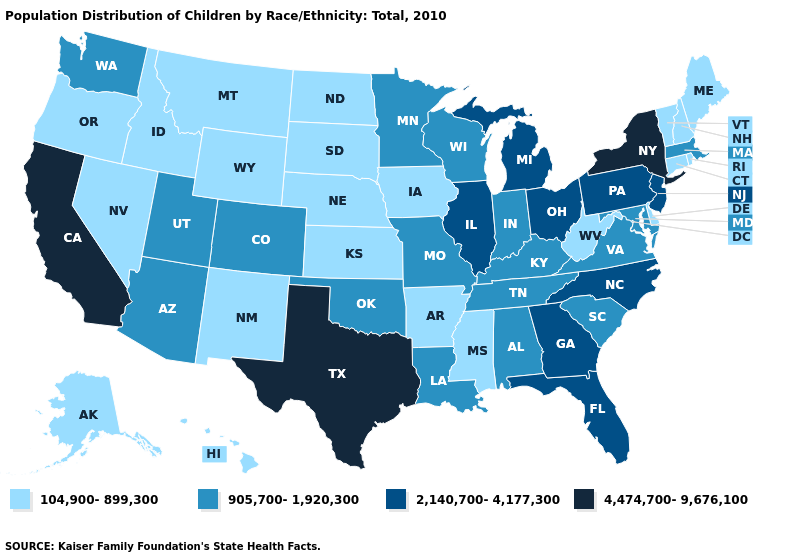What is the highest value in states that border Connecticut?
Keep it brief. 4,474,700-9,676,100. Does Florida have the highest value in the USA?
Answer briefly. No. Does the map have missing data?
Be succinct. No. What is the value of Connecticut?
Concise answer only. 104,900-899,300. Which states have the lowest value in the Northeast?
Quick response, please. Connecticut, Maine, New Hampshire, Rhode Island, Vermont. Which states hav the highest value in the MidWest?
Keep it brief. Illinois, Michigan, Ohio. Name the states that have a value in the range 905,700-1,920,300?
Be succinct. Alabama, Arizona, Colorado, Indiana, Kentucky, Louisiana, Maryland, Massachusetts, Minnesota, Missouri, Oklahoma, South Carolina, Tennessee, Utah, Virginia, Washington, Wisconsin. Name the states that have a value in the range 104,900-899,300?
Quick response, please. Alaska, Arkansas, Connecticut, Delaware, Hawaii, Idaho, Iowa, Kansas, Maine, Mississippi, Montana, Nebraska, Nevada, New Hampshire, New Mexico, North Dakota, Oregon, Rhode Island, South Dakota, Vermont, West Virginia, Wyoming. What is the lowest value in the Northeast?
Answer briefly. 104,900-899,300. What is the value of Arkansas?
Write a very short answer. 104,900-899,300. Does the map have missing data?
Keep it brief. No. Name the states that have a value in the range 104,900-899,300?
Give a very brief answer. Alaska, Arkansas, Connecticut, Delaware, Hawaii, Idaho, Iowa, Kansas, Maine, Mississippi, Montana, Nebraska, Nevada, New Hampshire, New Mexico, North Dakota, Oregon, Rhode Island, South Dakota, Vermont, West Virginia, Wyoming. What is the value of Pennsylvania?
Keep it brief. 2,140,700-4,177,300. Among the states that border Arkansas , does Texas have the highest value?
Keep it brief. Yes. Name the states that have a value in the range 104,900-899,300?
Give a very brief answer. Alaska, Arkansas, Connecticut, Delaware, Hawaii, Idaho, Iowa, Kansas, Maine, Mississippi, Montana, Nebraska, Nevada, New Hampshire, New Mexico, North Dakota, Oregon, Rhode Island, South Dakota, Vermont, West Virginia, Wyoming. 